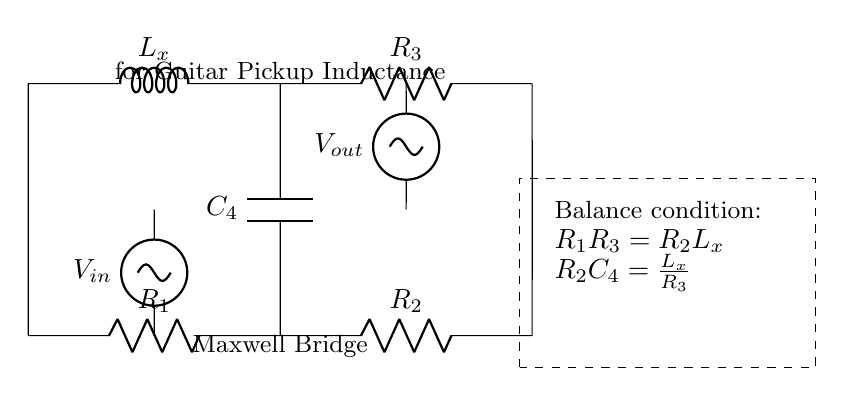What is the load component in this Maxwell bridge? The load component is represented by L_x, which is the inductor used for measuring inductance in the circuit.
Answer: L_x How many resistors are present in the circuit? There are three resistors labeled R_1, R_2, and R_3 in the circuit diagram.
Answer: Three What is the balance condition formula related to R_1 and R_3? The balance condition is given by the equation R_1R_3 = R_2L_x, which relates the values of the resistors to the inductance.
Answer: R_1R_3 = R_2L_x How is the input voltage denoted in the circuit? The input voltage is denoted as V_in, which is connected at the bottom left of the circuit and provides the signal for the bridge.
Answer: V_in What does C_4 represent in this Maxwell bridge? C_4 represents the capacitor in the circuit, which aids in balancing the inductive and resistive components.
Answer: Capacitor What is the purpose of this circuit? The purpose of the Maxwell bridge is to measure the inductance of components like guitar pickups and speaker coils by balancing the circuit.
Answer: Measure inductance 